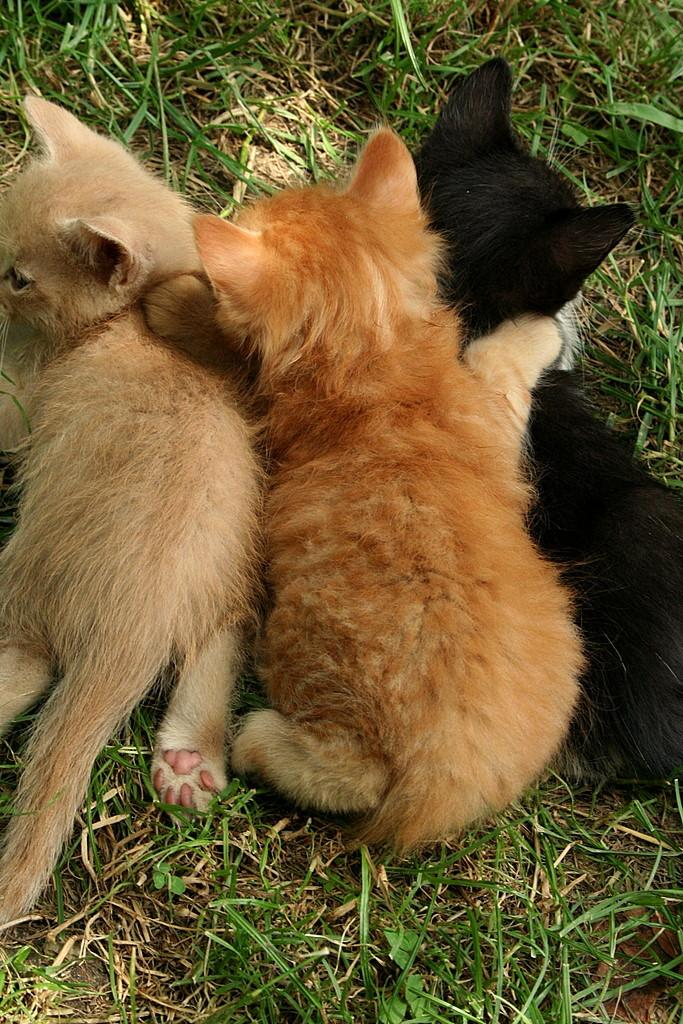What animals can be seen lying on the ground in the image? There are cats lying on the ground in the image. Can you describe the color of one of the cats? One of the cats is black in color. What type of vegetation is visible in the image? There is grass visible in the image. What type of dress is the rabbit wearing in the image? There is no rabbit present in the image, and therefore no dress or any attire can be observed. 